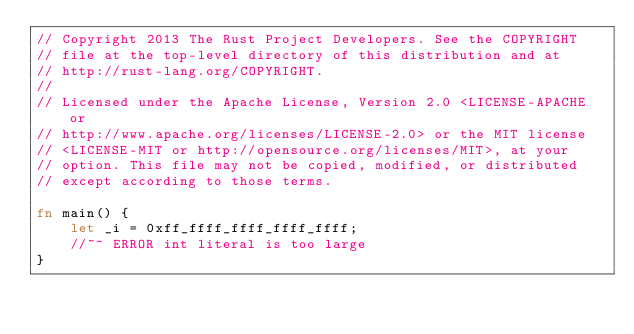Convert code to text. <code><loc_0><loc_0><loc_500><loc_500><_Rust_>// Copyright 2013 The Rust Project Developers. See the COPYRIGHT
// file at the top-level directory of this distribution and at
// http://rust-lang.org/COPYRIGHT.
//
// Licensed under the Apache License, Version 2.0 <LICENSE-APACHE or
// http://www.apache.org/licenses/LICENSE-2.0> or the MIT license
// <LICENSE-MIT or http://opensource.org/licenses/MIT>, at your
// option. This file may not be copied, modified, or distributed
// except according to those terms.

fn main() {
    let _i = 0xff_ffff_ffff_ffff_ffff;
    //~^ ERROR int literal is too large
}
</code> 